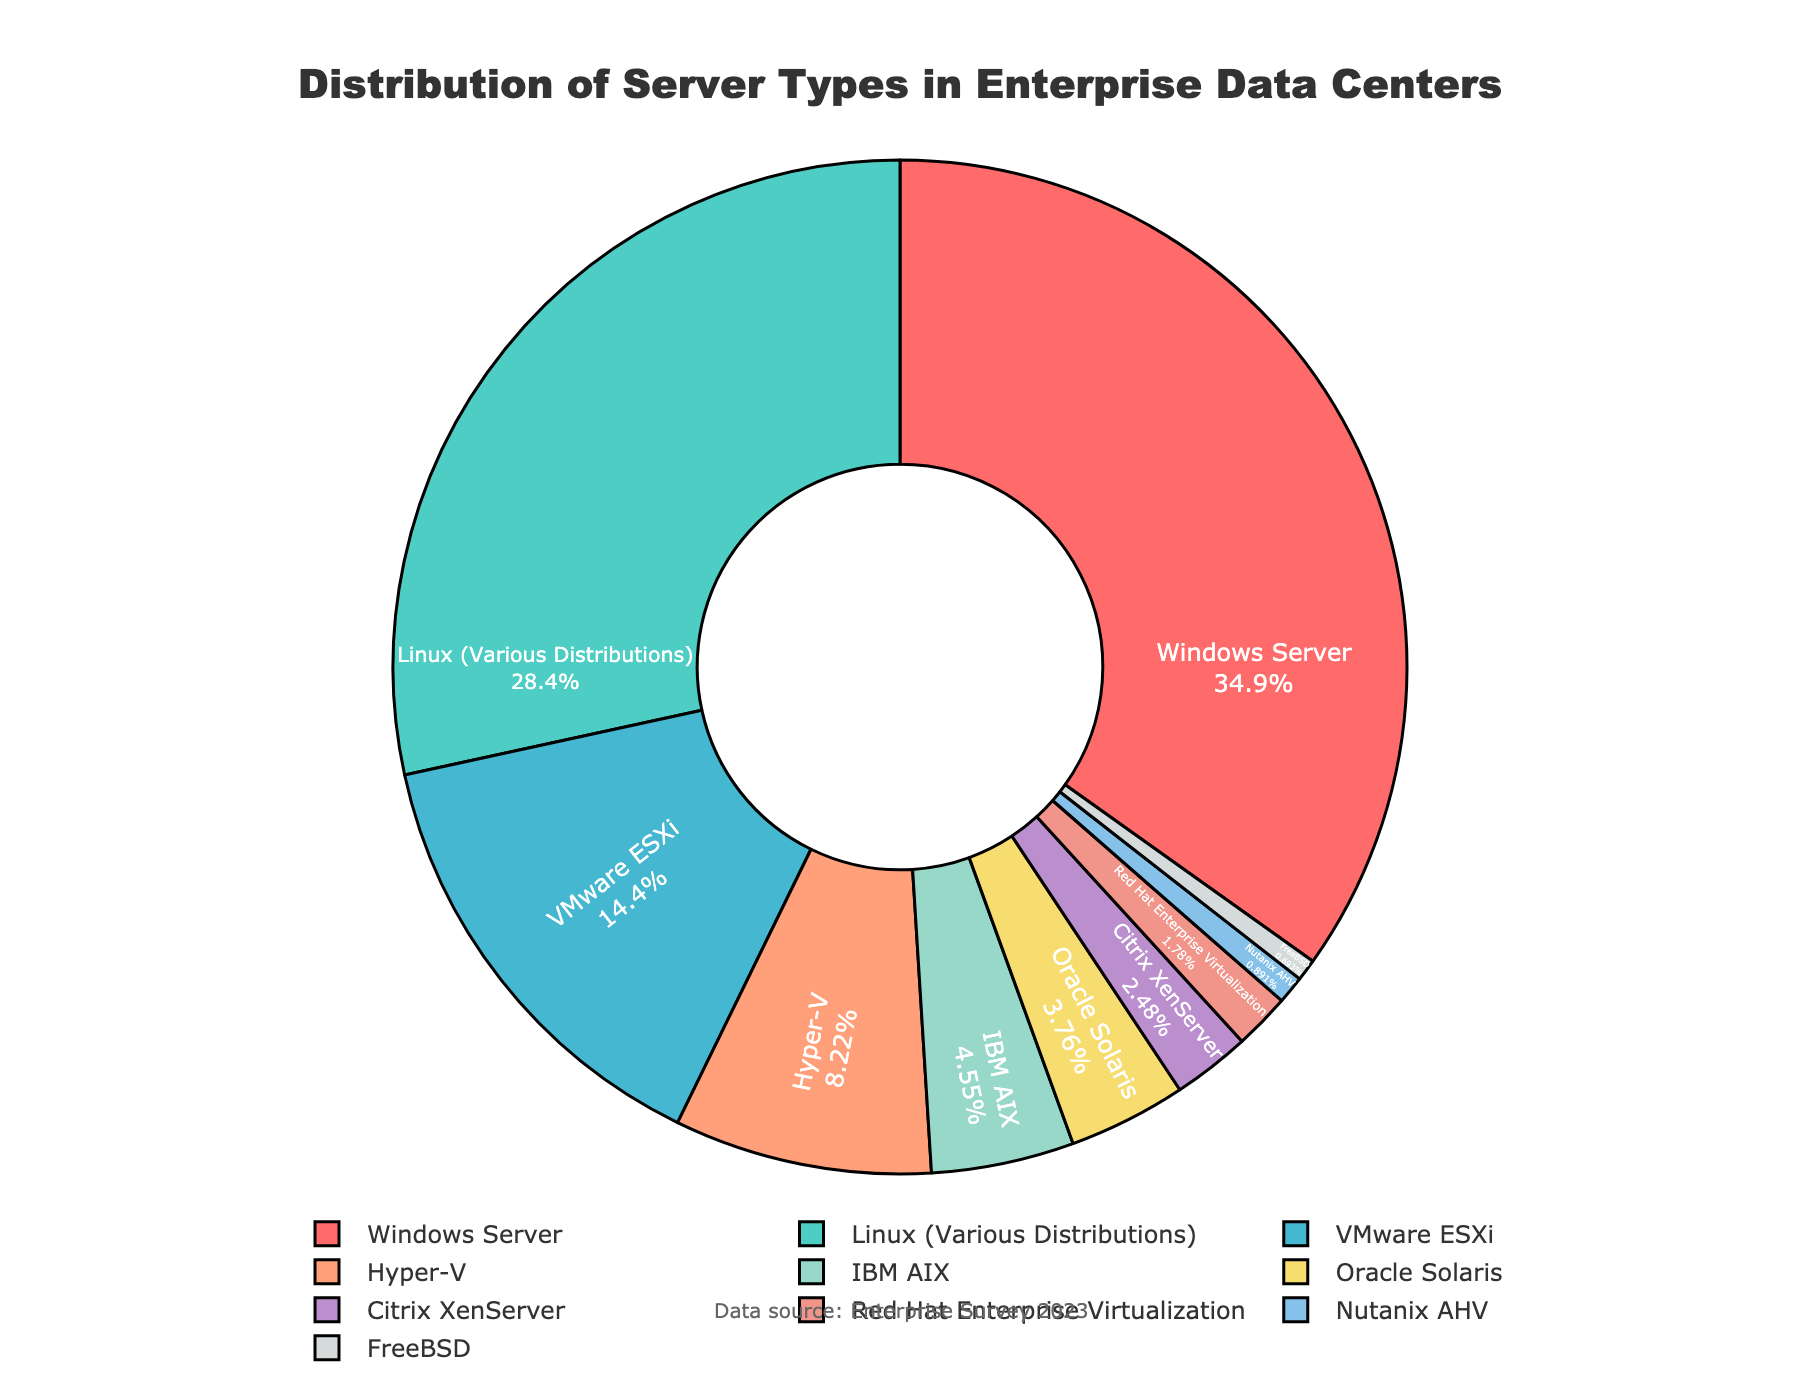What is the percentage of servers running Linux (Various Distributions)? According to the pie chart, the segment labeled "Linux (Various Distributions)" represents 28.7% of the total server distribution.
Answer: 28.7% Which server type has the smallest percentage in the distribution? By examining the pie chart, the segment labeled "FreeBSD" has the smallest percentage, clocking in at 0.7%.
Answer: FreeBSD What is the combined percentage of Windows Server and Linux (Various Distributions)? The pie chart shows that Windows Server has a percentage of 35.2% and Linux (Various Distributions) has 28.7%. Adding these together gives 35.2% + 28.7% = 63.9%.
Answer: 63.9% Compare the percentages of VMware ESXi and Hyper-V. Which one has a higher percentage and by how much? The pie chart indicates VMware ESXi has 14.5% while Hyper-V has 8.3%. The difference is 14.5% - 8.3% = 6.2%, with VMware ESXi having the higher percentage by 6.2%.
Answer: VMware ESXi by 6.2% How does the percentage of Oracle Solaris compare to IBM AIX? The pie chart shows Oracle Solaris at 3.8% and IBM AIX at 4.6%. Therefore, IBM AIX has a higher percentage than Oracle Solaris by 4.6% - 3.8% = 0.8%.
Answer: IBM AIX by 0.8% What is the total percentage of servers that are running virtualization platforms (VMware ESXi, Hyper-V, Citrix XenServer, Red Hat Enterprise Virtualization, Nutanix AHV)? Summing the percentages for VMware ESXi (14.5%), Hyper-V (8.3%), Citrix XenServer (2.5%), Red Hat Enterprise Virtualization (1.8%), and Nutanix AHV (0.9%) gives 14.5% + 8.3% + 2.5% + 1.8% + 0.9% = 28.0%.
Answer: 28.0% Which server type represents about one-third of the distribution? The pie chart shows that Windows Server represents 35.2% of the distribution, which is approximately one-third.
Answer: Windows Server What is the difference in percentage between the highest and lowest represented server types? The highest percentage is Windows Server at 35.2% and the lowest is FreeBSD at 0.7%. The difference is 35.2% - 0.7% = 34.5%.
Answer: 34.5% Describe the color and its visual positioning of the segment representing Linux (Various Distributions). In the pie chart, Linux (Various Distributions) is represented by a teal color and its segment is positioned roughly between the 1:00 and 2:00 position on the clock face.
Answer: Teal, between 1:00 and 2:00 What is the average percentage of the server types that have less than 5% distribution? The server types with less than 5% are IBM AIX (4.6%), Oracle Solaris (3.8%), Citrix XenServer (2.5%), Red Hat Enterprise Virtualization (1.8%), Nutanix AHV (0.9%), FreeBSD (0.7%). The total percentage is 4.6% + 3.8% + 2.5% + 1.8% + 0.9% + 0.7% = 14.3%. There are 6 types, so the average is 14.3% / 6 = 2.383%.
Answer: 2.383% 